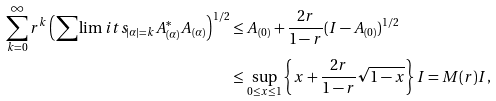<formula> <loc_0><loc_0><loc_500><loc_500>\sum _ { k = 0 } ^ { \infty } r ^ { k } \left ( \sum \lim i t s _ { | \alpha | = k } A _ { ( \alpha ) } ^ { * } A _ { ( \alpha ) } \right ) ^ { 1 / 2 } & \leq A _ { ( 0 ) } + \frac { 2 r } { 1 - r } ( I - A _ { ( 0 ) } ) ^ { 1 / 2 } \\ & \leq \sup _ { 0 \leq x \leq 1 } \left \{ x + \frac { 2 r } { 1 - r } \sqrt { 1 - x } \right \} I = M ( r ) I ,</formula> 